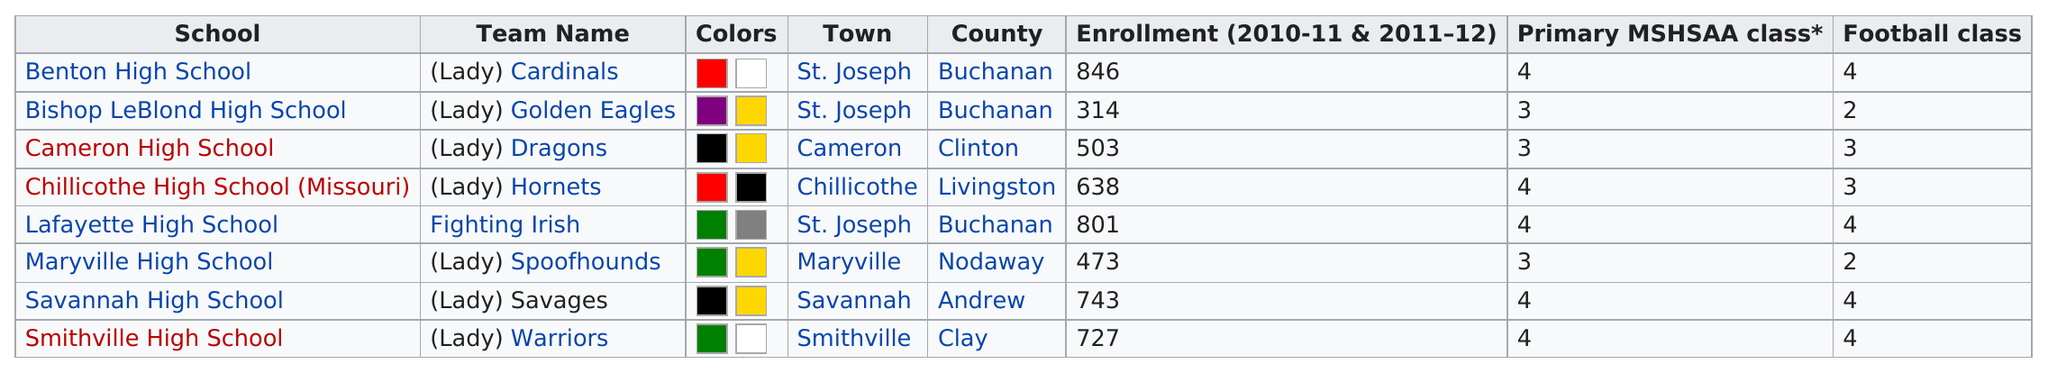Highlight a few significant elements in this photo. I hereby declare that Benton High School and Bishop Leblond High School are both located in the town of St. Joseph. Sixty-five percent of the schools had at least 500 students enrolled during the 2010-2011 and 2011-2012 academic seasons. Cameron High School is in the same football class as Chillicothe High School (Missouri). Benton High School has the largest enrollment among all schools. There are 8 schools in this conference. 